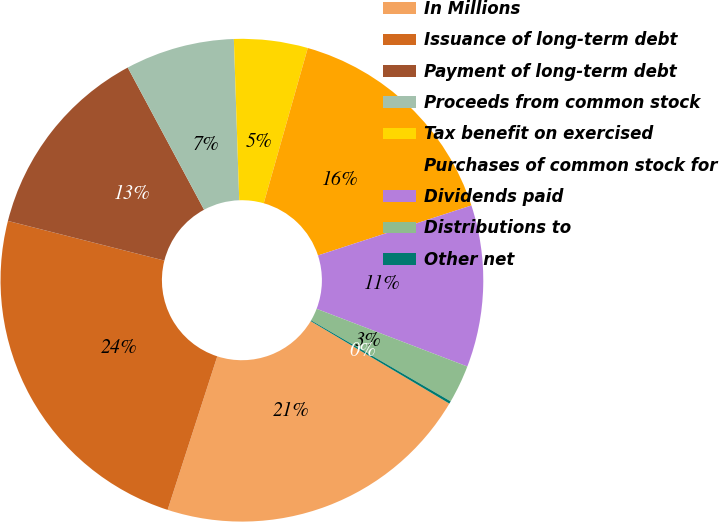<chart> <loc_0><loc_0><loc_500><loc_500><pie_chart><fcel>In Millions<fcel>Issuance of long-term debt<fcel>Payment of long-term debt<fcel>Proceeds from common stock<fcel>Tax benefit on exercised<fcel>Purchases of common stock for<fcel>Dividends paid<fcel>Distributions to<fcel>Other net<nl><fcel>21.44%<fcel>23.97%<fcel>13.21%<fcel>7.31%<fcel>4.93%<fcel>15.59%<fcel>10.83%<fcel>2.55%<fcel>0.17%<nl></chart> 